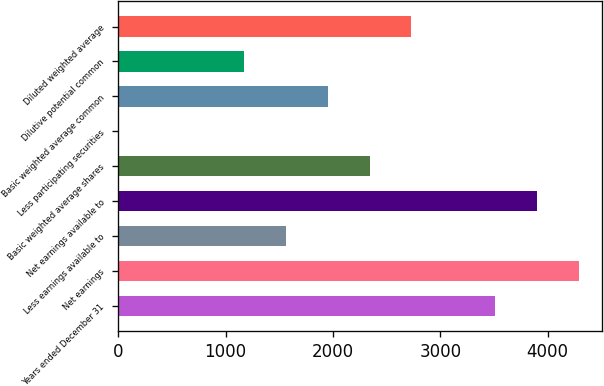Convert chart. <chart><loc_0><loc_0><loc_500><loc_500><bar_chart><fcel>Years ended December 31<fcel>Net earnings<fcel>Less earnings available to<fcel>Net earnings available to<fcel>Basic weighted average shares<fcel>Less participating securities<fcel>Basic weighted average common<fcel>Dilutive potential common<fcel>Diluted weighted average<nl><fcel>3510.23<fcel>4289.77<fcel>1561.38<fcel>3900<fcel>2340.92<fcel>2.3<fcel>1951.15<fcel>1171.61<fcel>2730.69<nl></chart> 